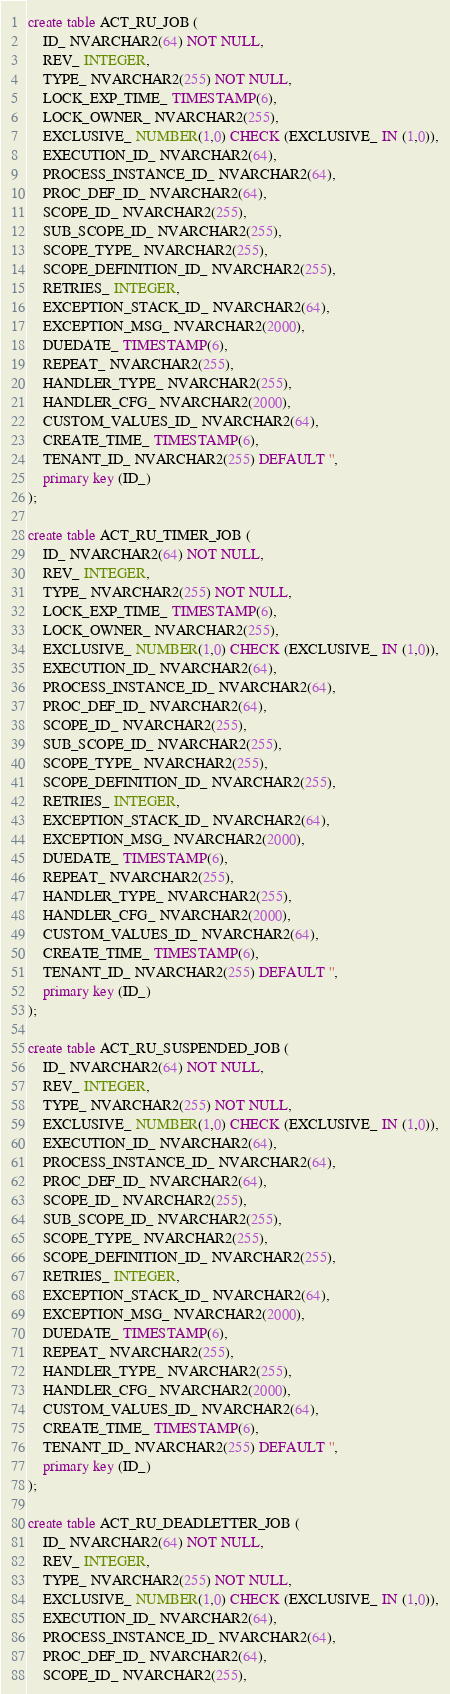Convert code to text. <code><loc_0><loc_0><loc_500><loc_500><_SQL_>create table ACT_RU_JOB (
    ID_ NVARCHAR2(64) NOT NULL,
    REV_ INTEGER,
    TYPE_ NVARCHAR2(255) NOT NULL,
    LOCK_EXP_TIME_ TIMESTAMP(6),
    LOCK_OWNER_ NVARCHAR2(255),
    EXCLUSIVE_ NUMBER(1,0) CHECK (EXCLUSIVE_ IN (1,0)),
    EXECUTION_ID_ NVARCHAR2(64),
    PROCESS_INSTANCE_ID_ NVARCHAR2(64),
    PROC_DEF_ID_ NVARCHAR2(64),
    SCOPE_ID_ NVARCHAR2(255),
    SUB_SCOPE_ID_ NVARCHAR2(255),
    SCOPE_TYPE_ NVARCHAR2(255),
    SCOPE_DEFINITION_ID_ NVARCHAR2(255),
    RETRIES_ INTEGER,
    EXCEPTION_STACK_ID_ NVARCHAR2(64),
    EXCEPTION_MSG_ NVARCHAR2(2000),
    DUEDATE_ TIMESTAMP(6),
    REPEAT_ NVARCHAR2(255),
    HANDLER_TYPE_ NVARCHAR2(255),
    HANDLER_CFG_ NVARCHAR2(2000),
    CUSTOM_VALUES_ID_ NVARCHAR2(64),
    CREATE_TIME_ TIMESTAMP(6),
    TENANT_ID_ NVARCHAR2(255) DEFAULT '',
    primary key (ID_)
);

create table ACT_RU_TIMER_JOB (
    ID_ NVARCHAR2(64) NOT NULL,
    REV_ INTEGER,
    TYPE_ NVARCHAR2(255) NOT NULL,
    LOCK_EXP_TIME_ TIMESTAMP(6),
    LOCK_OWNER_ NVARCHAR2(255),
    EXCLUSIVE_ NUMBER(1,0) CHECK (EXCLUSIVE_ IN (1,0)),
    EXECUTION_ID_ NVARCHAR2(64),
    PROCESS_INSTANCE_ID_ NVARCHAR2(64),
    PROC_DEF_ID_ NVARCHAR2(64),
    SCOPE_ID_ NVARCHAR2(255),
    SUB_SCOPE_ID_ NVARCHAR2(255),
    SCOPE_TYPE_ NVARCHAR2(255),
    SCOPE_DEFINITION_ID_ NVARCHAR2(255),
    RETRIES_ INTEGER,
    EXCEPTION_STACK_ID_ NVARCHAR2(64),
    EXCEPTION_MSG_ NVARCHAR2(2000),
    DUEDATE_ TIMESTAMP(6),
    REPEAT_ NVARCHAR2(255),
    HANDLER_TYPE_ NVARCHAR2(255),
    HANDLER_CFG_ NVARCHAR2(2000),
    CUSTOM_VALUES_ID_ NVARCHAR2(64),
    CREATE_TIME_ TIMESTAMP(6),
    TENANT_ID_ NVARCHAR2(255) DEFAULT '',
    primary key (ID_)
);

create table ACT_RU_SUSPENDED_JOB (
    ID_ NVARCHAR2(64) NOT NULL,
    REV_ INTEGER,
    TYPE_ NVARCHAR2(255) NOT NULL,
    EXCLUSIVE_ NUMBER(1,0) CHECK (EXCLUSIVE_ IN (1,0)),
    EXECUTION_ID_ NVARCHAR2(64),
    PROCESS_INSTANCE_ID_ NVARCHAR2(64),
    PROC_DEF_ID_ NVARCHAR2(64),
    SCOPE_ID_ NVARCHAR2(255),
    SUB_SCOPE_ID_ NVARCHAR2(255),
    SCOPE_TYPE_ NVARCHAR2(255),
    SCOPE_DEFINITION_ID_ NVARCHAR2(255),
    RETRIES_ INTEGER,
    EXCEPTION_STACK_ID_ NVARCHAR2(64),
    EXCEPTION_MSG_ NVARCHAR2(2000),
    DUEDATE_ TIMESTAMP(6),
    REPEAT_ NVARCHAR2(255),
    HANDLER_TYPE_ NVARCHAR2(255),
    HANDLER_CFG_ NVARCHAR2(2000),
    CUSTOM_VALUES_ID_ NVARCHAR2(64),
    CREATE_TIME_ TIMESTAMP(6),
    TENANT_ID_ NVARCHAR2(255) DEFAULT '',
    primary key (ID_)
);

create table ACT_RU_DEADLETTER_JOB (
    ID_ NVARCHAR2(64) NOT NULL,
    REV_ INTEGER,
    TYPE_ NVARCHAR2(255) NOT NULL,
    EXCLUSIVE_ NUMBER(1,0) CHECK (EXCLUSIVE_ IN (1,0)),
    EXECUTION_ID_ NVARCHAR2(64),
    PROCESS_INSTANCE_ID_ NVARCHAR2(64),
    PROC_DEF_ID_ NVARCHAR2(64),
    SCOPE_ID_ NVARCHAR2(255),</code> 